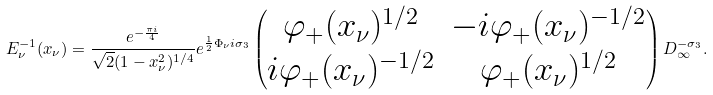Convert formula to latex. <formula><loc_0><loc_0><loc_500><loc_500>E _ { \nu } ^ { - 1 } ( x _ { \nu } ) = \frac { e ^ { - \frac { \pi i } { 4 } } } { \sqrt { 2 } ( 1 - x _ { \nu } ^ { 2 } ) ^ { 1 / 4 } } e ^ { \frac { 1 } { 2 } \Phi _ { \nu } i \sigma _ { 3 } } \begin{pmatrix} \varphi _ { + } ( x _ { \nu } ) ^ { 1 / 2 } & - i \varphi _ { + } ( x _ { \nu } ) ^ { - 1 / 2 } \\ i \varphi _ { + } ( x _ { \nu } ) ^ { - 1 / 2 } & \varphi _ { + } ( x _ { \nu } ) ^ { 1 / 2 } \end{pmatrix} D _ { \infty } ^ { - \sigma _ { 3 } } .</formula> 